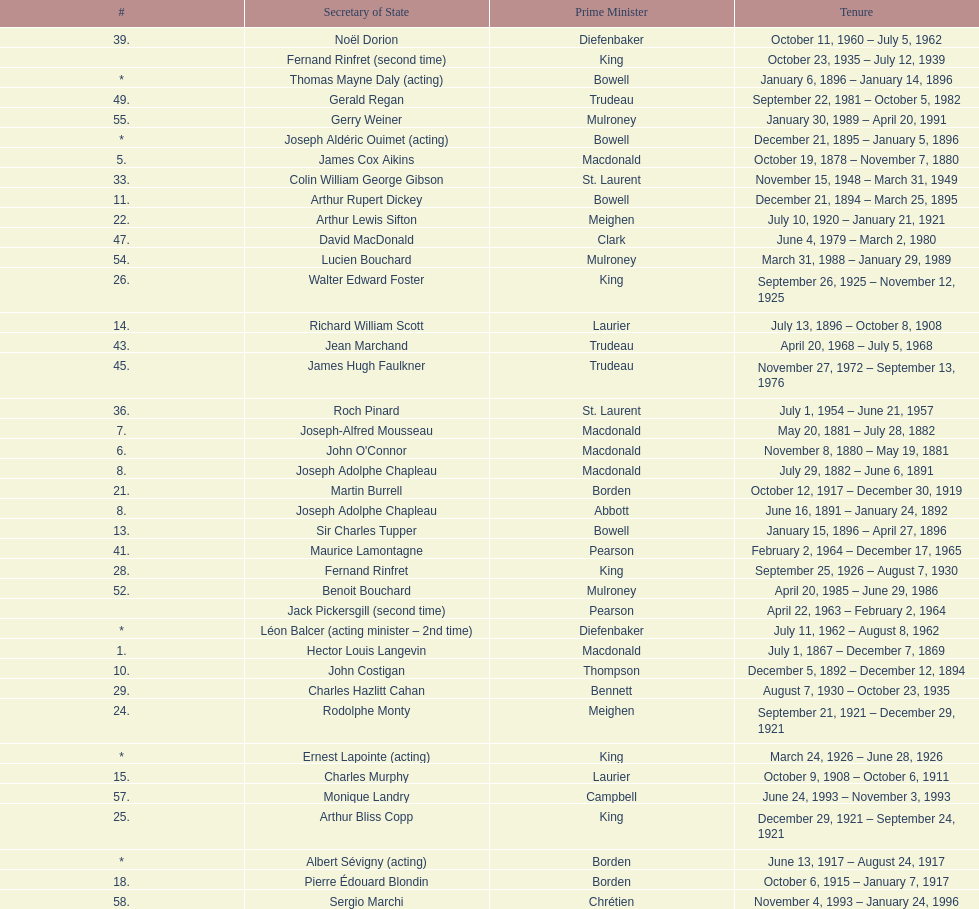I'm looking to parse the entire table for insights. Could you assist me with that? {'header': ['#', 'Secretary of State', 'Prime Minister', 'Tenure'], 'rows': [['39.', 'Noël Dorion', 'Diefenbaker', 'October 11, 1960 – July 5, 1962'], ['', 'Fernand Rinfret (second time)', 'King', 'October 23, 1935 – July 12, 1939'], ['*', 'Thomas Mayne Daly (acting)', 'Bowell', 'January 6, 1896 – January 14, 1896'], ['49.', 'Gerald Regan', 'Trudeau', 'September 22, 1981 – October 5, 1982'], ['55.', 'Gerry Weiner', 'Mulroney', 'January 30, 1989 – April 20, 1991'], ['*', 'Joseph Aldéric Ouimet (acting)', 'Bowell', 'December 21, 1895 – January 5, 1896'], ['5.', 'James Cox Aikins', 'Macdonald', 'October 19, 1878 – November 7, 1880'], ['33.', 'Colin William George Gibson', 'St. Laurent', 'November 15, 1948 – March 31, 1949'], ['11.', 'Arthur Rupert Dickey', 'Bowell', 'December 21, 1894 – March 25, 1895'], ['22.', 'Arthur Lewis Sifton', 'Meighen', 'July 10, 1920 – January 21, 1921'], ['47.', 'David MacDonald', 'Clark', 'June 4, 1979 – March 2, 1980'], ['54.', 'Lucien Bouchard', 'Mulroney', 'March 31, 1988 – January 29, 1989'], ['26.', 'Walter Edward Foster', 'King', 'September 26, 1925 – November 12, 1925'], ['14.', 'Richard William Scott', 'Laurier', 'July 13, 1896 – October 8, 1908'], ['43.', 'Jean Marchand', 'Trudeau', 'April 20, 1968 – July 5, 1968'], ['45.', 'James Hugh Faulkner', 'Trudeau', 'November 27, 1972 – September 13, 1976'], ['36.', 'Roch Pinard', 'St. Laurent', 'July 1, 1954 – June 21, 1957'], ['7.', 'Joseph-Alfred Mousseau', 'Macdonald', 'May 20, 1881 – July 28, 1882'], ['6.', "John O'Connor", 'Macdonald', 'November 8, 1880 – May 19, 1881'], ['8.', 'Joseph Adolphe Chapleau', 'Macdonald', 'July 29, 1882 – June 6, 1891'], ['21.', 'Martin Burrell', 'Borden', 'October 12, 1917 – December 30, 1919'], ['8.', 'Joseph Adolphe Chapleau', 'Abbott', 'June 16, 1891 – January 24, 1892'], ['13.', 'Sir Charles Tupper', 'Bowell', 'January 15, 1896 – April 27, 1896'], ['41.', 'Maurice Lamontagne', 'Pearson', 'February 2, 1964 – December 17, 1965'], ['28.', 'Fernand Rinfret', 'King', 'September 25, 1926 – August 7, 1930'], ['52.', 'Benoit Bouchard', 'Mulroney', 'April 20, 1985 – June 29, 1986'], ['', 'Jack Pickersgill (second time)', 'Pearson', 'April 22, 1963 – February 2, 1964'], ['*', 'Léon Balcer (acting minister – 2nd time)', 'Diefenbaker', 'July 11, 1962 – August 8, 1962'], ['1.', 'Hector Louis Langevin', 'Macdonald', 'July 1, 1867 – December 7, 1869'], ['10.', 'John Costigan', 'Thompson', 'December 5, 1892 – December 12, 1894'], ['29.', 'Charles Hazlitt Cahan', 'Bennett', 'August 7, 1930 – October 23, 1935'], ['24.', 'Rodolphe Monty', 'Meighen', 'September 21, 1921 – December 29, 1921'], ['*', 'Ernest Lapointe (acting)', 'King', 'March 24, 1926 – June 28, 1926'], ['15.', 'Charles Murphy', 'Laurier', 'October 9, 1908 – October 6, 1911'], ['57.', 'Monique Landry', 'Campbell', 'June 24, 1993 – November 3, 1993'], ['25.', 'Arthur Bliss Copp', 'King', 'December 29, 1921 – September 24, 1921'], ['*', 'Albert Sévigny (acting)', 'Borden', 'June 13, 1917 – August 24, 1917'], ['18.', 'Pierre Édouard Blondin', 'Borden', 'October 6, 1915 – January 7, 1917'], ['58.', 'Sergio Marchi', 'Chrétien', 'November 4, 1993 – January 24, 1996'], ['17.', 'Louis Coderre', 'Borden', 'October 29, 1912 – October 5, 1915'], ['4.', 'Richard William Scott', 'Mackenzie', 'January 9, 1874 – October 8, 1878'], ['27.', 'Guillaume André Fauteux', 'Meighen', 'August 23, 1926 – September 25, 1926'], ['16.', 'William James Roche', 'Borden', 'October 10, 1911 – October 28, 1912'], ['57.', 'Monique Landry', 'Mulroney', 'January 4, 1993 – June 24, 1993'], ['51.', 'Walter McLean', 'Mulroney', 'September 17, 1984 – April 19, 1985'], ['37.', 'Ellen Louks Fairclough', 'Diefenbaker', 'June 21, 1957 – May 11, 1958'], ['53.', 'David Crombie', 'Mulroney', 'June 30, 1986 – March 30, 1988'], ['31.', 'Norman Alexander McLarty', 'King', 'December 15, 1941 – April 17, 1945'], ['*', 'Charles Murphy (acting)', 'King', 'November 13, 1925 – March 23, 1926'], ['19.', 'Esioff Léon Patenaude', 'Borden', 'January 8, 1917 – June 12, 1917'], ['*', 'Ernest Lapointe (acting – 2nd time)', 'King', 'July 26, 1939 – May 8, 1940'], ['38.', 'Henri Courtemanche', 'Diefenbaker', 'May 12, 1958 – June 19, 1960'], ['44.', 'Gérard Pelletier', 'Trudeau', 'July 5, 1968 – November 26, 1972'], ['40.', 'George Ernest Halpenny', 'Diefenbaker', 'August 9, 1962 – April 22, 1963'], ['50.', 'Serge Joyal', 'Turner', 'June 30, 1984 – September 16, 1984'], ['42.', 'Judy LaMarsh', 'Pearson', 'December 17, 1965 – April 9, 1968'], ['23.', 'Sir Henry Lumley Drayton', 'Meighen', 'January 24, 1921 – September 20, 1921'], ['33.', 'Colin William George Gibson', 'King', 'December 12, 1946 – November 15, 1948'], ['56.', 'Robert de Cotret', 'Mulroney', 'April 21, 1991 – January 3, 1993'], ['*', 'Léon Balcer (acting minister)', 'Diefenbaker', 'June 21, 1960 – October 10, 1960'], ['13.', 'Sir Charles Tupper', 'as PM', 'May 1, 1896 – July 8, 1896'], ['59.', 'Lucienne Robillard', 'Chrétien', 'January 25, 1996 – July 12, 1996'], ['48.', 'Francis Fox', 'Trudeau', 'March 3, 1980 – September 21, 1981'], ['34.', 'Frederick Gordon Bradley', 'St. Laurent', 'March 31, 1949 – June 11, 1953'], ['50.', 'Serge Joyal', 'Trudeau', 'October 6, 1982 – June 29, 1984'], ['20.', 'Arthur Meighen', 'Borden', 'August 25, 1917 – October 12, 1917'], ['32.', 'Paul Joseph James Martin', 'King', 'April 18, 1945 – December 11, 1946'], ['35.', 'Jack Pickersgill', 'St. Laurent', 'June 11, 1953 – June 30, 1954'], ['9.', 'James Colebrooke Patterson', 'Abbott', 'January 25, 1892 – November 24, 1892'], ['22.', 'Arthur Lewis Sifton', 'Borden', 'December 31, 1919 – July 10, 1920'], ['46.', 'John Roberts', 'Trudeau', 'September 14, 1976 – June 3, 1979'], ['3.', 'David Christie', 'Mackenzie', 'November 7, 1873 – January 8, 1874'], ['30.', 'Pierre-François Casgrain', 'King', 'May 9, 1940 – December 14, 1941'], ['*', 'John Joseph Connolly (acting minister)', 'Pearson', 'April 10, 1968 – April 20, 1968'], ['2.', 'James Cox Aikins', 'Macdonald', 'December 8, 1867 – November 5, 1873'], ['12.', 'Walter Humphries Montague', 'Bowell', 'March 26, 1895 – December 20, 1895']]} How many secretaries of state had the last name bouchard? 2. 